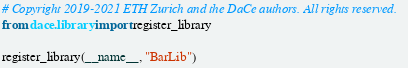<code> <loc_0><loc_0><loc_500><loc_500><_Python_># Copyright 2019-2021 ETH Zurich and the DaCe authors. All rights reserved.
from dace.library import register_library

register_library(__name__, "BarLib")
</code> 